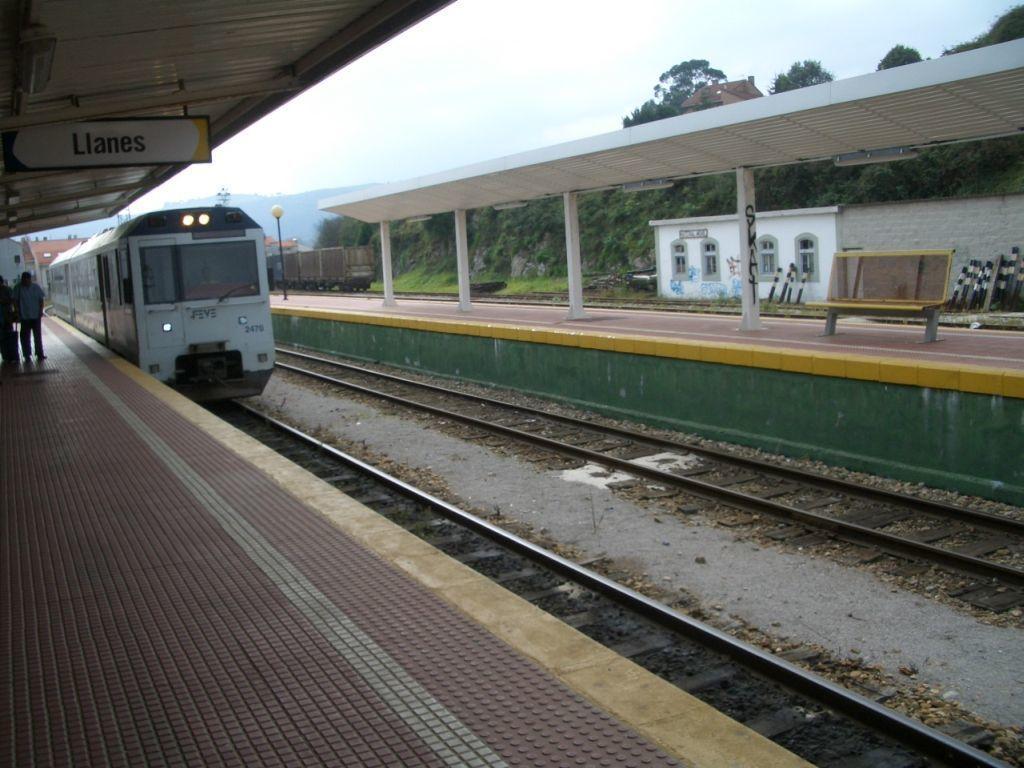Describe this image in one or two sentences. This picture might be taken inside a railway station. In this image, on the left side, we can see a man, suitcase, hoardings and a train moving on the railway track. On the right side, we can also see a bench, trees, train, street light, plants, building, glass window. In the background, we can also see some mountains. At the top, we can see a sky. 